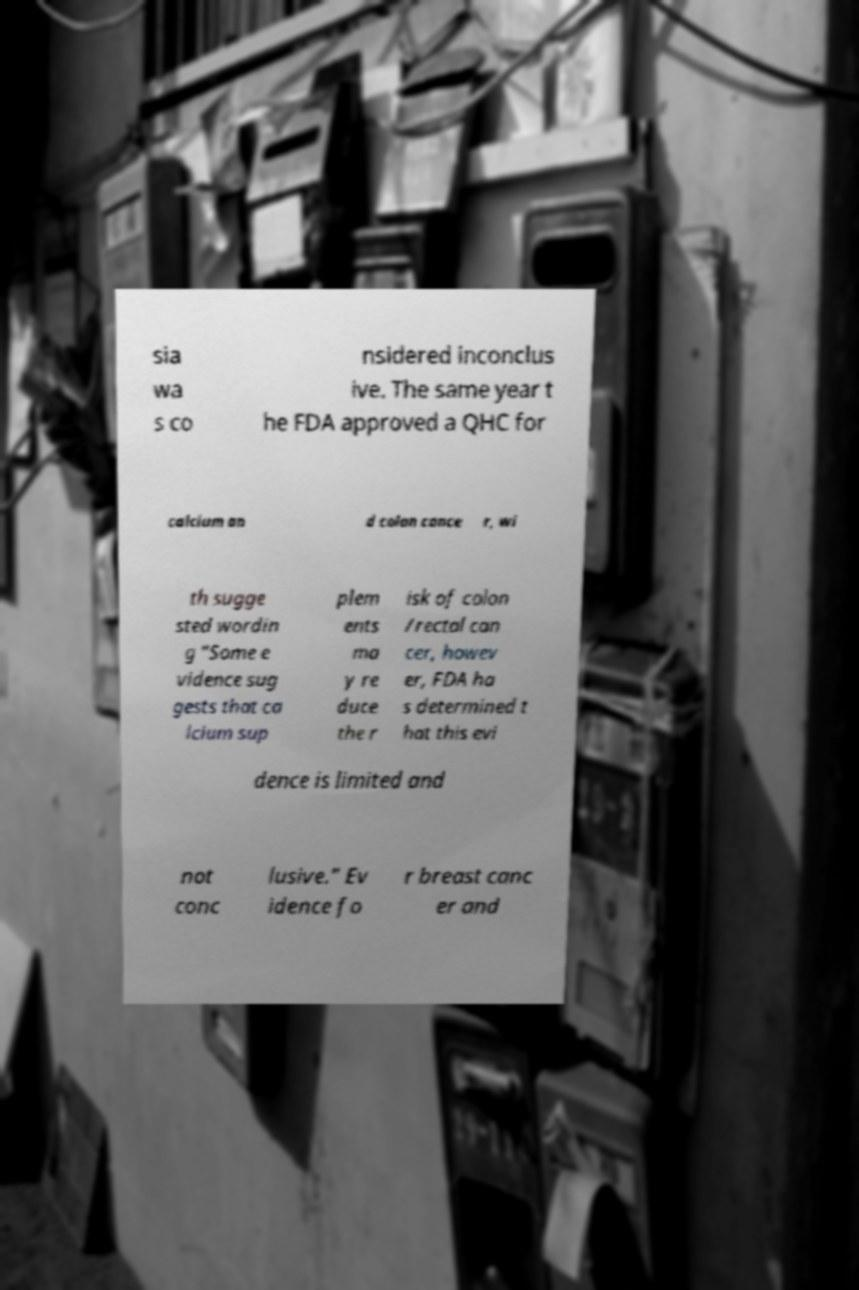Could you extract and type out the text from this image? sia wa s co nsidered inconclus ive. The same year t he FDA approved a QHC for calcium an d colon cance r, wi th sugge sted wordin g "Some e vidence sug gests that ca lcium sup plem ents ma y re duce the r isk of colon /rectal can cer, howev er, FDA ha s determined t hat this evi dence is limited and not conc lusive." Ev idence fo r breast canc er and 